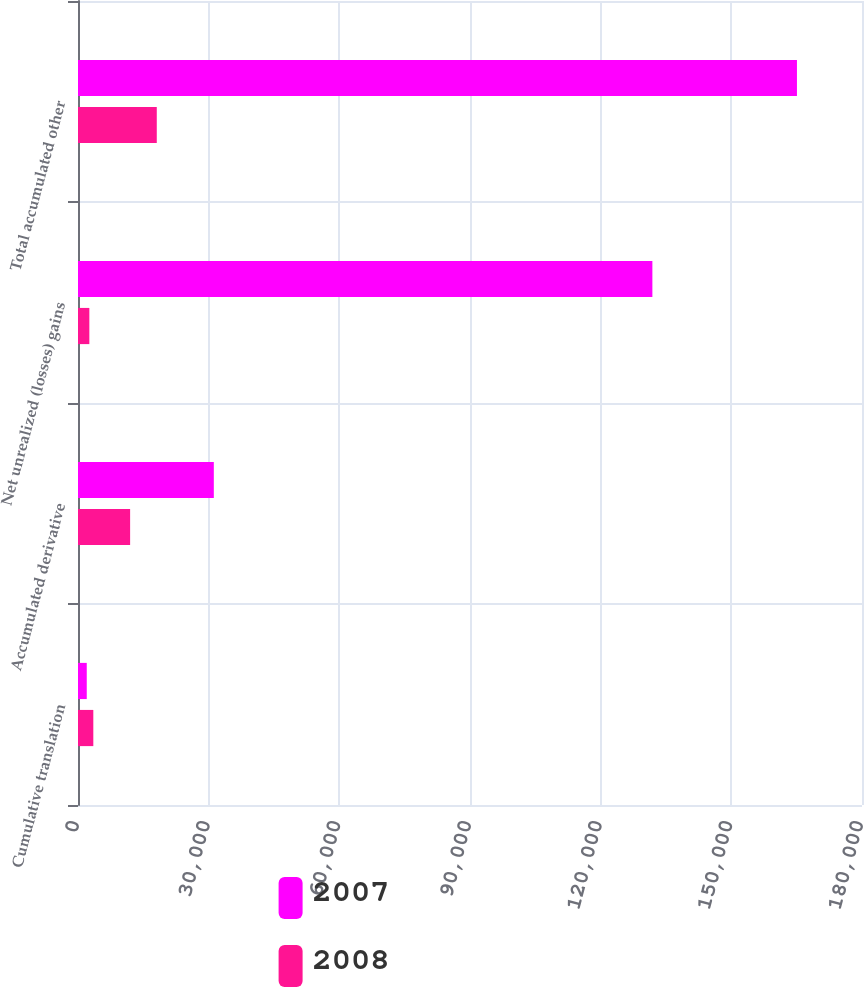Convert chart. <chart><loc_0><loc_0><loc_500><loc_500><stacked_bar_chart><ecel><fcel>Cumulative translation<fcel>Accumulated derivative<fcel>Net unrealized (losses) gains<fcel>Total accumulated other<nl><fcel>2007<fcel>2011<fcel>31183<fcel>131872<fcel>165066<nl><fcel>2008<fcel>3516<fcel>11966<fcel>2605<fcel>18087<nl></chart> 